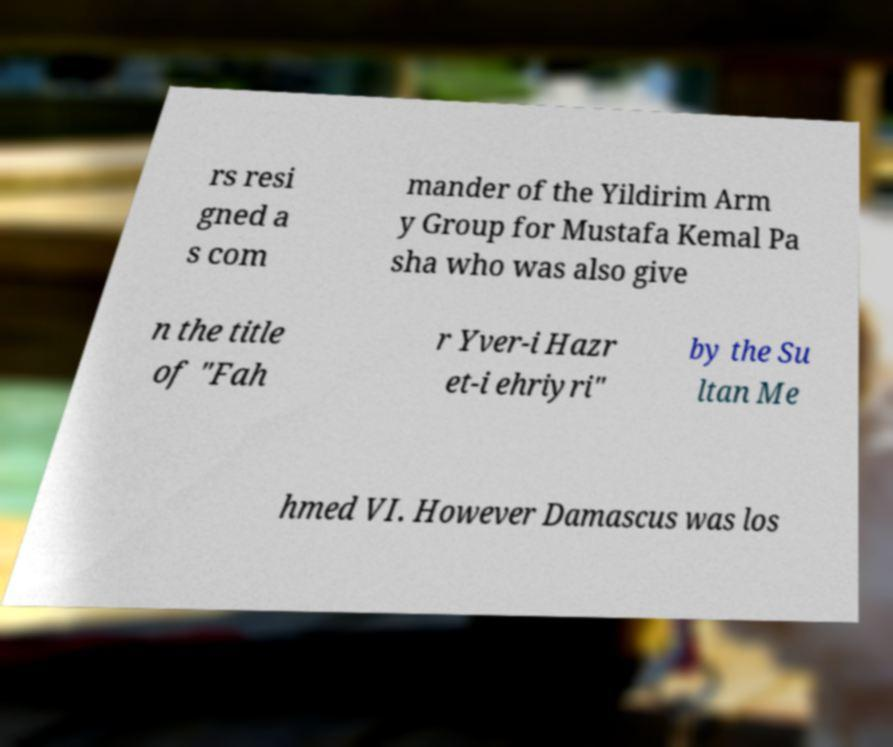Could you extract and type out the text from this image? rs resi gned a s com mander of the Yildirim Arm y Group for Mustafa Kemal Pa sha who was also give n the title of "Fah r Yver-i Hazr et-i ehriyri" by the Su ltan Me hmed VI. However Damascus was los 